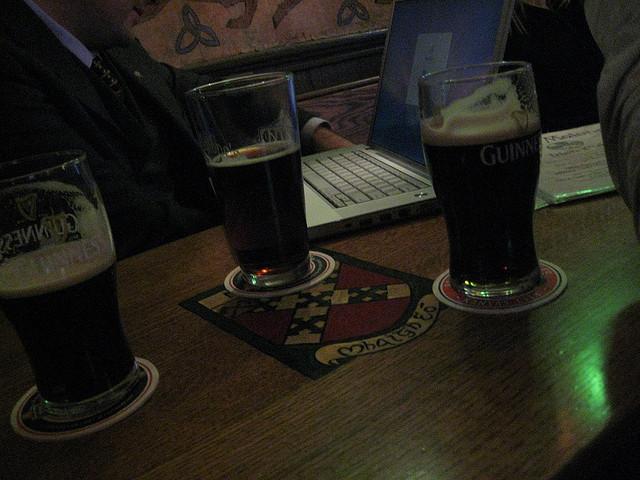Is this a bar?
Answer briefly. Yes. Why is this glass so empty?
Answer briefly. Drinking. How many of these objects are not electronic?
Concise answer only. 3. How many glasses are there?
Short answer required. 3. What is the image imprinted on the table?
Quick response, please. Crest. What kind of cup is this?
Give a very brief answer. Beer glass. 